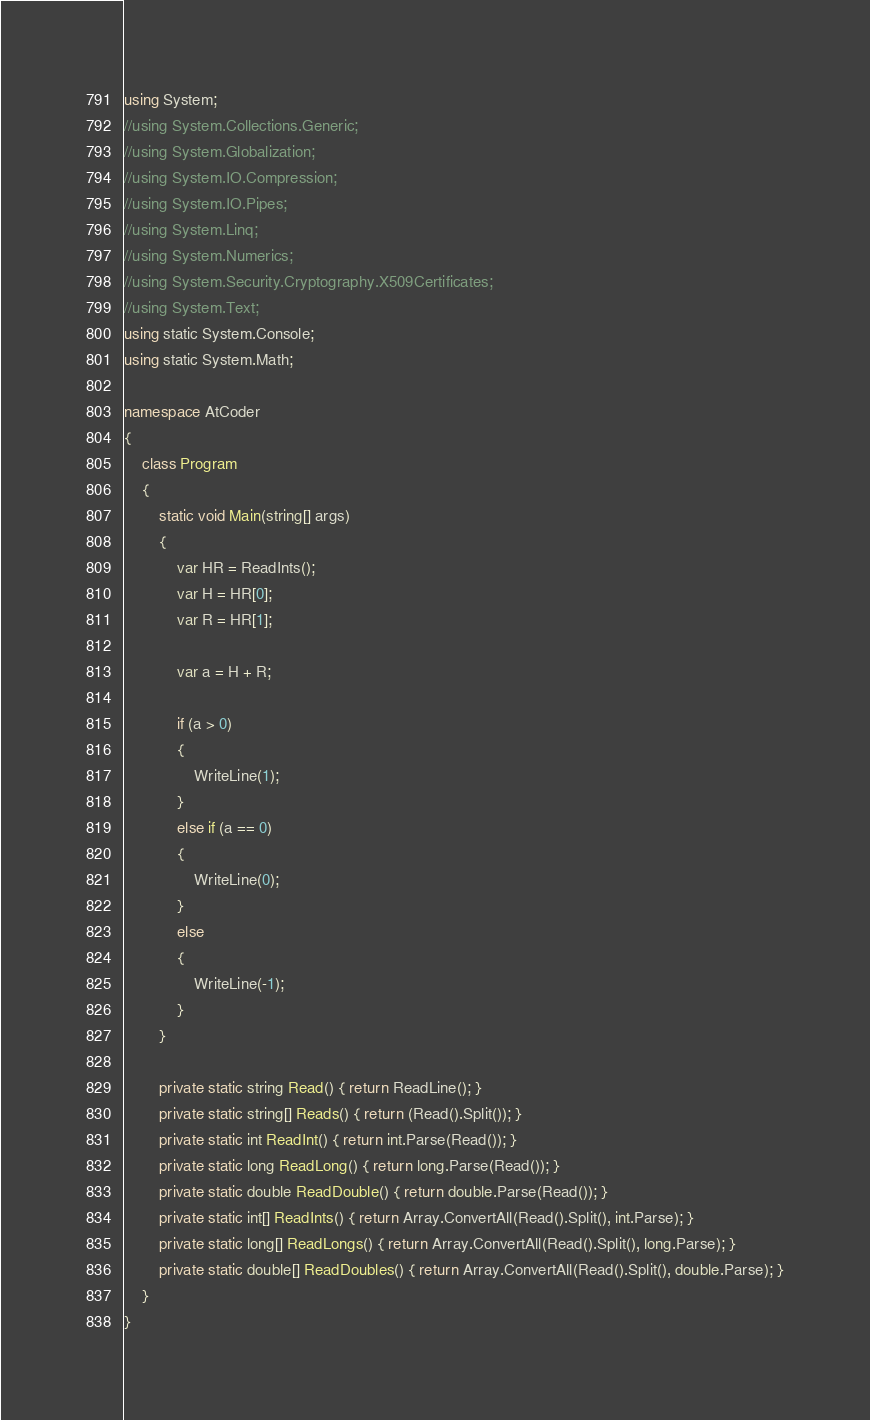<code> <loc_0><loc_0><loc_500><loc_500><_C#_>using System;
//using System.Collections.Generic;
//using System.Globalization;
//using System.IO.Compression;
//using System.IO.Pipes;
//using System.Linq;
//using System.Numerics;
//using System.Security.Cryptography.X509Certificates;
//using System.Text;
using static System.Console;
using static System.Math;

namespace AtCoder
{
    class Program
    {
        static void Main(string[] args)
        {
            var HR = ReadInts();
            var H = HR[0];
            var R = HR[1];

            var a = H + R;

            if (a > 0)
            {
                WriteLine(1);
            }
            else if (a == 0)
            {
                WriteLine(0);
            }
            else
            {
                WriteLine(-1);
            }
        }

        private static string Read() { return ReadLine(); }
        private static string[] Reads() { return (Read().Split()); }
        private static int ReadInt() { return int.Parse(Read()); }
        private static long ReadLong() { return long.Parse(Read()); }
        private static double ReadDouble() { return double.Parse(Read()); }
        private static int[] ReadInts() { return Array.ConvertAll(Read().Split(), int.Parse); }
        private static long[] ReadLongs() { return Array.ConvertAll(Read().Split(), long.Parse); }
        private static double[] ReadDoubles() { return Array.ConvertAll(Read().Split(), double.Parse); }
    }
}

</code> 